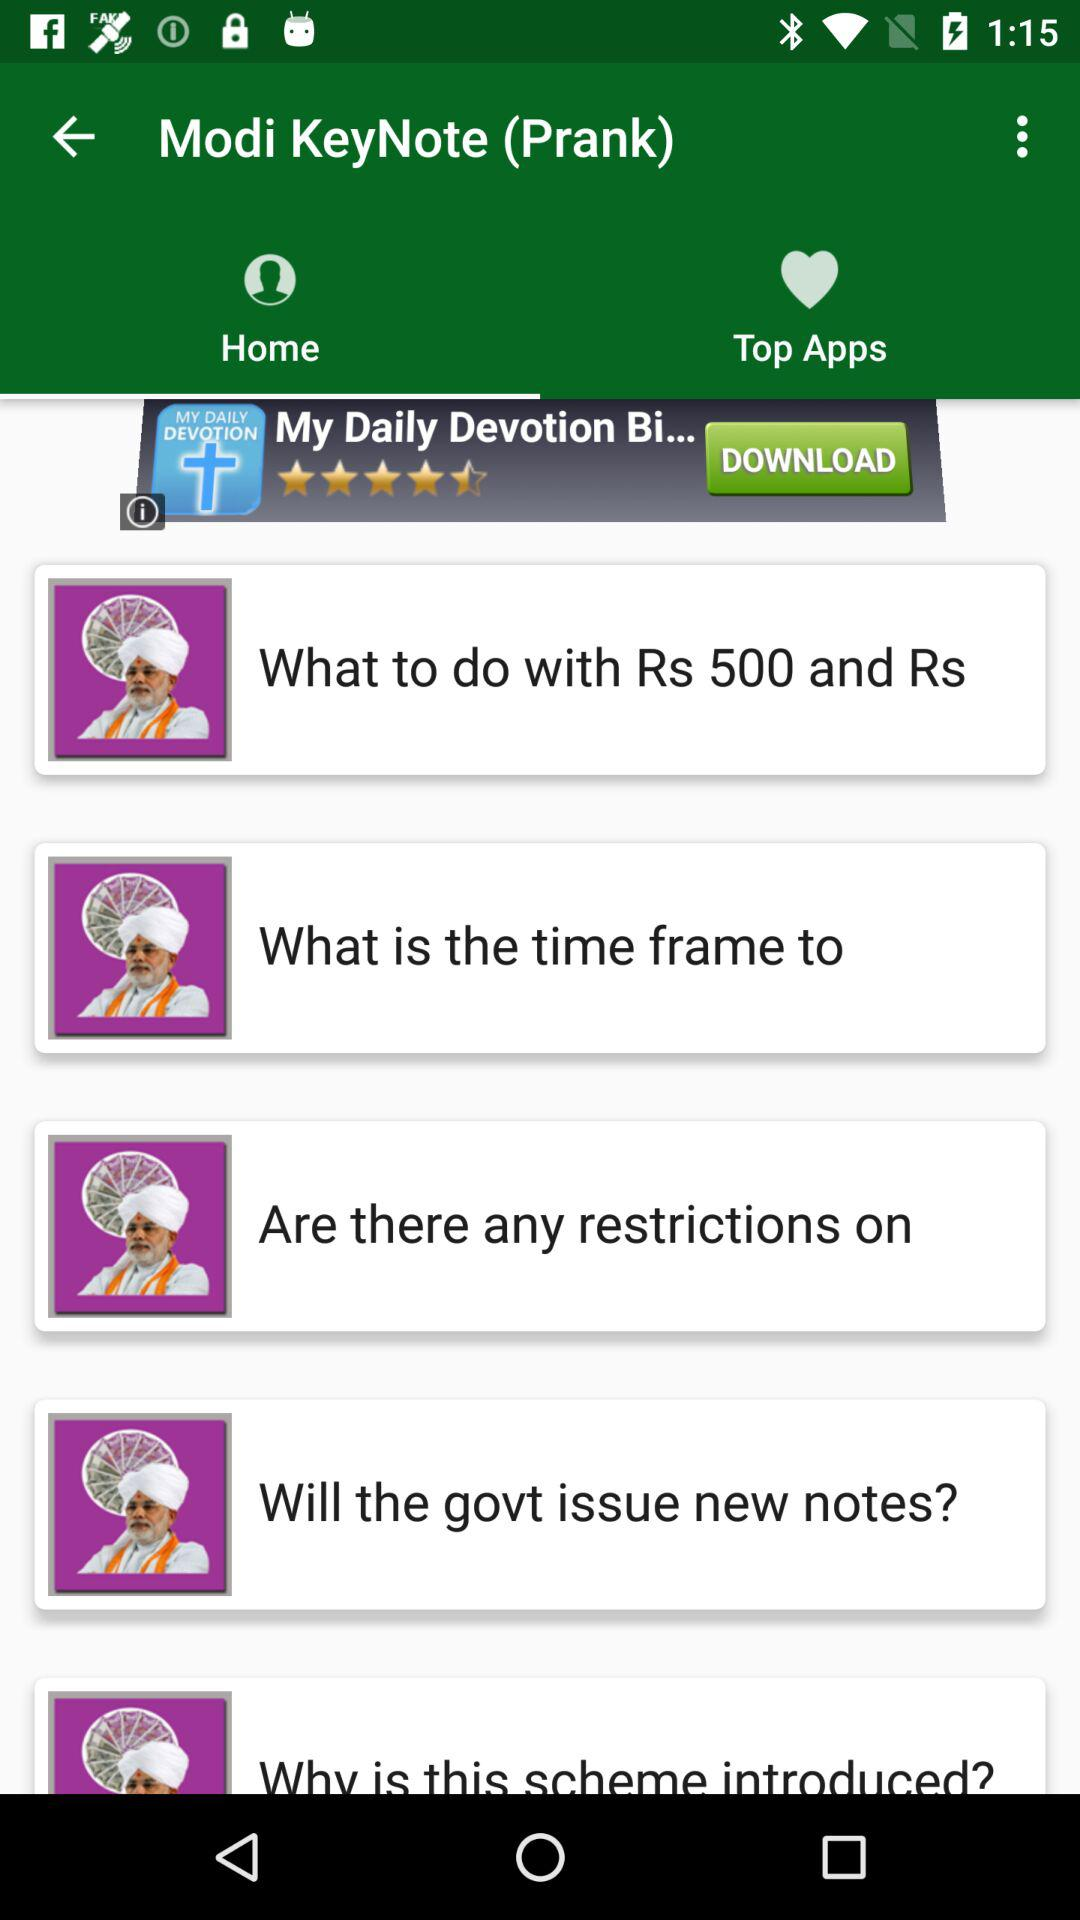Which tab is selected? The selected tab is "Home". 